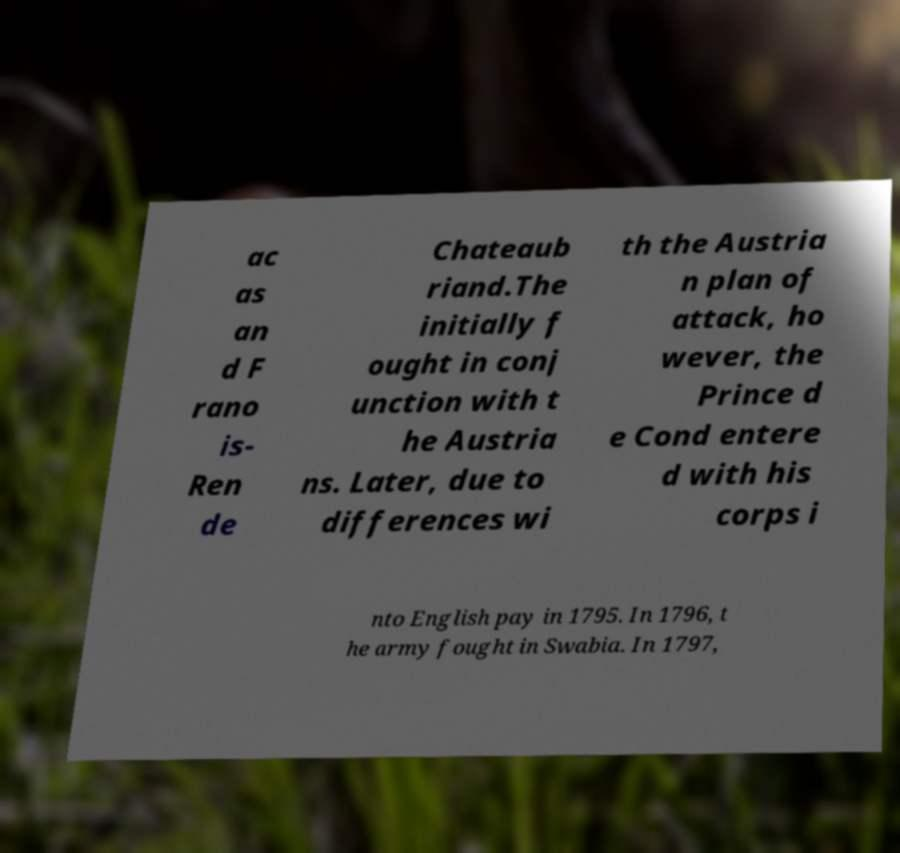Could you assist in decoding the text presented in this image and type it out clearly? ac as an d F rano is- Ren de Chateaub riand.The initially f ought in conj unction with t he Austria ns. Later, due to differences wi th the Austria n plan of attack, ho wever, the Prince d e Cond entere d with his corps i nto English pay in 1795. In 1796, t he army fought in Swabia. In 1797, 